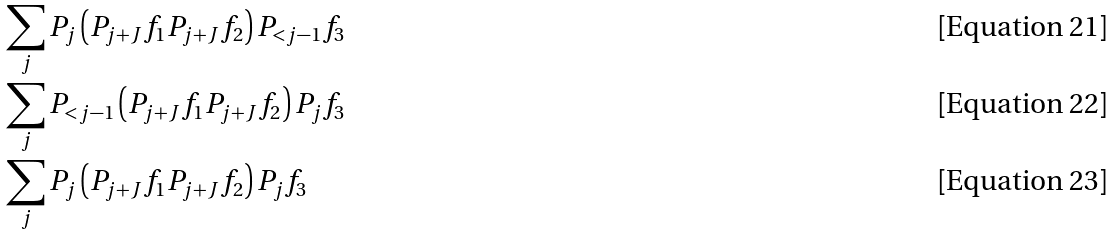<formula> <loc_0><loc_0><loc_500><loc_500>& \sum _ { j } P _ { j } \left ( P _ { j + J } f _ { 1 } P _ { j + J } f _ { 2 } \right ) P _ { < j - 1 } f _ { 3 } \\ & \sum _ { j } P _ { < j - 1 } \left ( P _ { j + J } f _ { 1 } P _ { j + J } f _ { 2 } \right ) P _ { j } f _ { 3 } \\ & \sum _ { j } P _ { j } \left ( P _ { j + J } f _ { 1 } P _ { j + J } f _ { 2 } \right ) P _ { j } f _ { 3 }</formula> 